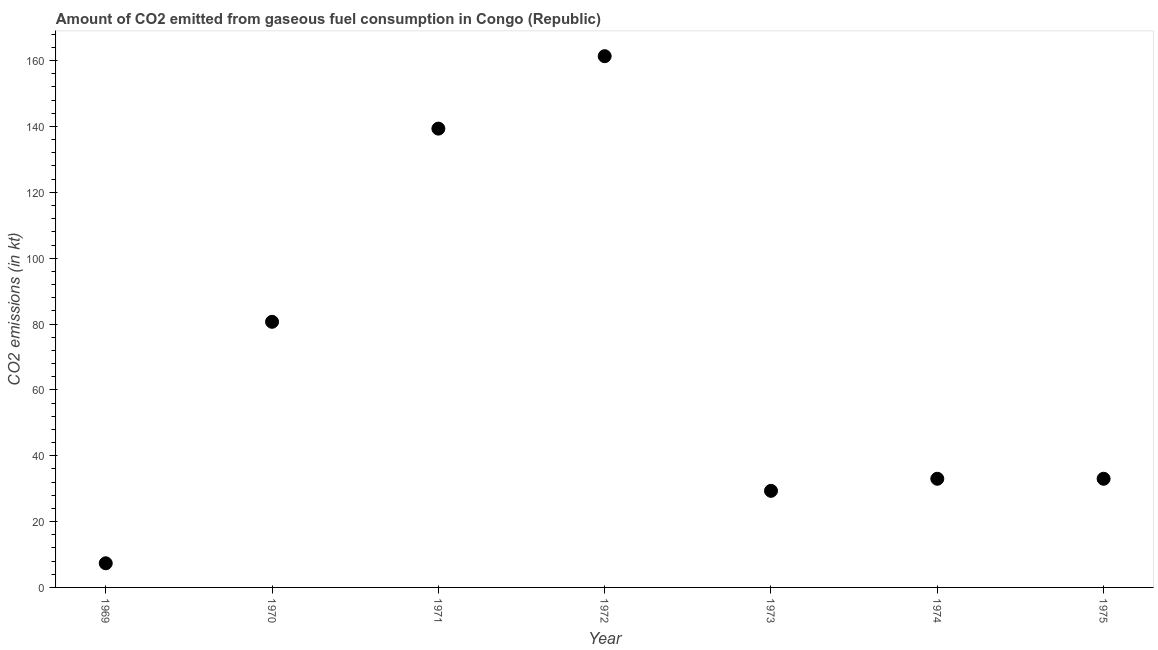What is the co2 emissions from gaseous fuel consumption in 1970?
Provide a succinct answer. 80.67. Across all years, what is the maximum co2 emissions from gaseous fuel consumption?
Ensure brevity in your answer.  161.35. Across all years, what is the minimum co2 emissions from gaseous fuel consumption?
Keep it short and to the point. 7.33. In which year was the co2 emissions from gaseous fuel consumption maximum?
Offer a terse response. 1972. In which year was the co2 emissions from gaseous fuel consumption minimum?
Your response must be concise. 1969. What is the sum of the co2 emissions from gaseous fuel consumption?
Your answer should be very brief. 484.04. What is the difference between the co2 emissions from gaseous fuel consumption in 1970 and 1973?
Provide a succinct answer. 51.34. What is the average co2 emissions from gaseous fuel consumption per year?
Offer a very short reply. 69.15. What is the median co2 emissions from gaseous fuel consumption?
Provide a succinct answer. 33. In how many years, is the co2 emissions from gaseous fuel consumption greater than 92 kt?
Give a very brief answer. 2. Do a majority of the years between 1970 and 1972 (inclusive) have co2 emissions from gaseous fuel consumption greater than 160 kt?
Offer a very short reply. No. Is the difference between the co2 emissions from gaseous fuel consumption in 1969 and 1972 greater than the difference between any two years?
Provide a short and direct response. Yes. What is the difference between the highest and the second highest co2 emissions from gaseous fuel consumption?
Ensure brevity in your answer.  22. Is the sum of the co2 emissions from gaseous fuel consumption in 1973 and 1975 greater than the maximum co2 emissions from gaseous fuel consumption across all years?
Keep it short and to the point. No. What is the difference between the highest and the lowest co2 emissions from gaseous fuel consumption?
Keep it short and to the point. 154.01. Does the co2 emissions from gaseous fuel consumption monotonically increase over the years?
Give a very brief answer. No. What is the difference between two consecutive major ticks on the Y-axis?
Ensure brevity in your answer.  20. Are the values on the major ticks of Y-axis written in scientific E-notation?
Ensure brevity in your answer.  No. Does the graph contain any zero values?
Provide a succinct answer. No. Does the graph contain grids?
Make the answer very short. No. What is the title of the graph?
Give a very brief answer. Amount of CO2 emitted from gaseous fuel consumption in Congo (Republic). What is the label or title of the X-axis?
Your response must be concise. Year. What is the label or title of the Y-axis?
Give a very brief answer. CO2 emissions (in kt). What is the CO2 emissions (in kt) in 1969?
Make the answer very short. 7.33. What is the CO2 emissions (in kt) in 1970?
Keep it short and to the point. 80.67. What is the CO2 emissions (in kt) in 1971?
Provide a succinct answer. 139.35. What is the CO2 emissions (in kt) in 1972?
Your response must be concise. 161.35. What is the CO2 emissions (in kt) in 1973?
Offer a terse response. 29.34. What is the CO2 emissions (in kt) in 1974?
Ensure brevity in your answer.  33. What is the CO2 emissions (in kt) in 1975?
Your answer should be very brief. 33. What is the difference between the CO2 emissions (in kt) in 1969 and 1970?
Offer a very short reply. -73.34. What is the difference between the CO2 emissions (in kt) in 1969 and 1971?
Offer a very short reply. -132.01. What is the difference between the CO2 emissions (in kt) in 1969 and 1972?
Your response must be concise. -154.01. What is the difference between the CO2 emissions (in kt) in 1969 and 1973?
Your answer should be very brief. -22. What is the difference between the CO2 emissions (in kt) in 1969 and 1974?
Make the answer very short. -25.67. What is the difference between the CO2 emissions (in kt) in 1969 and 1975?
Your answer should be compact. -25.67. What is the difference between the CO2 emissions (in kt) in 1970 and 1971?
Keep it short and to the point. -58.67. What is the difference between the CO2 emissions (in kt) in 1970 and 1972?
Make the answer very short. -80.67. What is the difference between the CO2 emissions (in kt) in 1970 and 1973?
Offer a very short reply. 51.34. What is the difference between the CO2 emissions (in kt) in 1970 and 1974?
Offer a terse response. 47.67. What is the difference between the CO2 emissions (in kt) in 1970 and 1975?
Your answer should be compact. 47.67. What is the difference between the CO2 emissions (in kt) in 1971 and 1972?
Keep it short and to the point. -22. What is the difference between the CO2 emissions (in kt) in 1971 and 1973?
Provide a short and direct response. 110.01. What is the difference between the CO2 emissions (in kt) in 1971 and 1974?
Provide a succinct answer. 106.34. What is the difference between the CO2 emissions (in kt) in 1971 and 1975?
Provide a succinct answer. 106.34. What is the difference between the CO2 emissions (in kt) in 1972 and 1973?
Provide a short and direct response. 132.01. What is the difference between the CO2 emissions (in kt) in 1972 and 1974?
Keep it short and to the point. 128.34. What is the difference between the CO2 emissions (in kt) in 1972 and 1975?
Your response must be concise. 128.34. What is the difference between the CO2 emissions (in kt) in 1973 and 1974?
Your answer should be compact. -3.67. What is the difference between the CO2 emissions (in kt) in 1973 and 1975?
Provide a short and direct response. -3.67. What is the ratio of the CO2 emissions (in kt) in 1969 to that in 1970?
Offer a terse response. 0.09. What is the ratio of the CO2 emissions (in kt) in 1969 to that in 1971?
Your response must be concise. 0.05. What is the ratio of the CO2 emissions (in kt) in 1969 to that in 1972?
Provide a succinct answer. 0.04. What is the ratio of the CO2 emissions (in kt) in 1969 to that in 1973?
Your answer should be compact. 0.25. What is the ratio of the CO2 emissions (in kt) in 1969 to that in 1974?
Ensure brevity in your answer.  0.22. What is the ratio of the CO2 emissions (in kt) in 1969 to that in 1975?
Your answer should be compact. 0.22. What is the ratio of the CO2 emissions (in kt) in 1970 to that in 1971?
Your response must be concise. 0.58. What is the ratio of the CO2 emissions (in kt) in 1970 to that in 1973?
Offer a terse response. 2.75. What is the ratio of the CO2 emissions (in kt) in 1970 to that in 1974?
Offer a very short reply. 2.44. What is the ratio of the CO2 emissions (in kt) in 1970 to that in 1975?
Your answer should be compact. 2.44. What is the ratio of the CO2 emissions (in kt) in 1971 to that in 1972?
Your answer should be compact. 0.86. What is the ratio of the CO2 emissions (in kt) in 1971 to that in 1973?
Give a very brief answer. 4.75. What is the ratio of the CO2 emissions (in kt) in 1971 to that in 1974?
Give a very brief answer. 4.22. What is the ratio of the CO2 emissions (in kt) in 1971 to that in 1975?
Provide a succinct answer. 4.22. What is the ratio of the CO2 emissions (in kt) in 1972 to that in 1974?
Your answer should be compact. 4.89. What is the ratio of the CO2 emissions (in kt) in 1972 to that in 1975?
Give a very brief answer. 4.89. What is the ratio of the CO2 emissions (in kt) in 1973 to that in 1974?
Offer a very short reply. 0.89. What is the ratio of the CO2 emissions (in kt) in 1973 to that in 1975?
Your response must be concise. 0.89. 